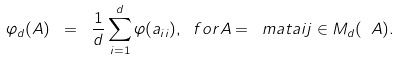Convert formula to latex. <formula><loc_0><loc_0><loc_500><loc_500>\varphi _ { d } ( A ) \ = \ \frac { 1 } { d } \sum _ { i = 1 } ^ { d } \varphi ( a _ { i i } ) , \ f o r A = \ m a t a i j \in M _ { d } ( \ A ) .</formula> 